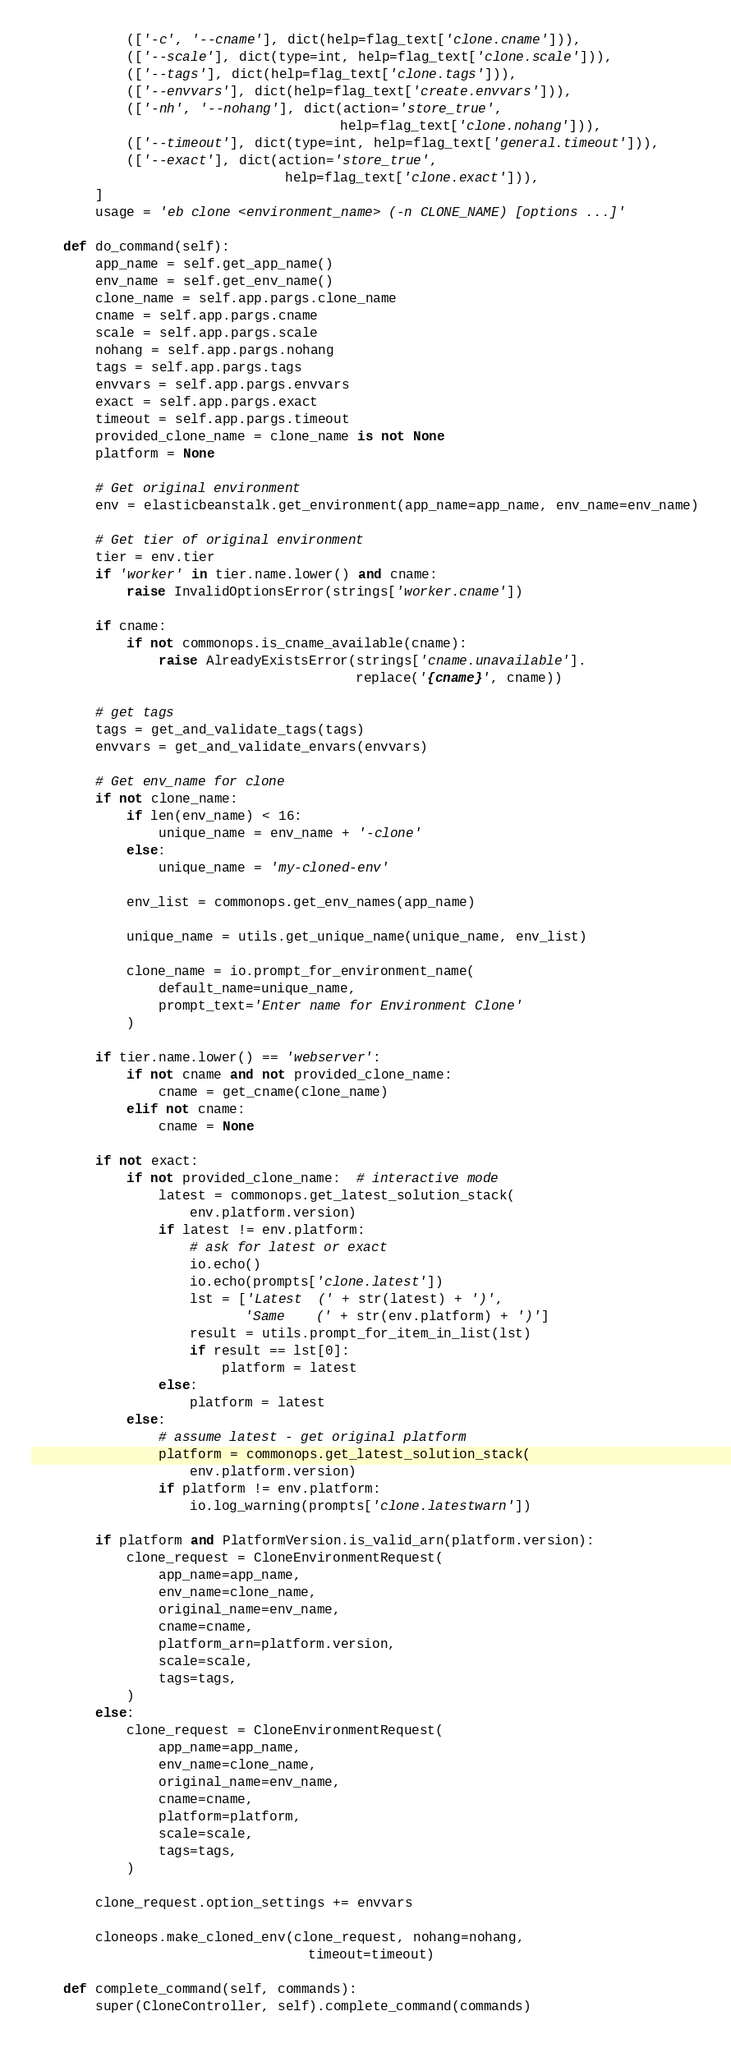<code> <loc_0><loc_0><loc_500><loc_500><_Python_>            (['-c', '--cname'], dict(help=flag_text['clone.cname'])),
            (['--scale'], dict(type=int, help=flag_text['clone.scale'])),
            (['--tags'], dict(help=flag_text['clone.tags'])),
            (['--envvars'], dict(help=flag_text['create.envvars'])),
            (['-nh', '--nohang'], dict(action='store_true',
                                       help=flag_text['clone.nohang'])),
            (['--timeout'], dict(type=int, help=flag_text['general.timeout'])),
            (['--exact'], dict(action='store_true',
                                help=flag_text['clone.exact'])),
        ]
        usage = 'eb clone <environment_name> (-n CLONE_NAME) [options ...]'

    def do_command(self):
        app_name = self.get_app_name()
        env_name = self.get_env_name()
        clone_name = self.app.pargs.clone_name
        cname = self.app.pargs.cname
        scale = self.app.pargs.scale
        nohang = self.app.pargs.nohang
        tags = self.app.pargs.tags
        envvars = self.app.pargs.envvars
        exact = self.app.pargs.exact
        timeout = self.app.pargs.timeout
        provided_clone_name = clone_name is not None
        platform = None

        # Get original environment
        env = elasticbeanstalk.get_environment(app_name=app_name, env_name=env_name)

        # Get tier of original environment
        tier = env.tier
        if 'worker' in tier.name.lower() and cname:
            raise InvalidOptionsError(strings['worker.cname'])

        if cname:
            if not commonops.is_cname_available(cname):
                raise AlreadyExistsError(strings['cname.unavailable'].
                                         replace('{cname}', cname))

        # get tags
        tags = get_and_validate_tags(tags)
        envvars = get_and_validate_envars(envvars)

        # Get env_name for clone
        if not clone_name:
            if len(env_name) < 16:
                unique_name = env_name + '-clone'
            else:
                unique_name = 'my-cloned-env'

            env_list = commonops.get_env_names(app_name)

            unique_name = utils.get_unique_name(unique_name, env_list)

            clone_name = io.prompt_for_environment_name(
                default_name=unique_name,
                prompt_text='Enter name for Environment Clone'
            )

        if tier.name.lower() == 'webserver':
            if not cname and not provided_clone_name:
                cname = get_cname(clone_name)
            elif not cname:
                cname = None

        if not exact:
            if not provided_clone_name:  # interactive mode
                latest = commonops.get_latest_solution_stack(
                    env.platform.version)
                if latest != env.platform:
                    # ask for latest or exact
                    io.echo()
                    io.echo(prompts['clone.latest'])
                    lst = ['Latest  (' + str(latest) + ')',
                           'Same    (' + str(env.platform) + ')']
                    result = utils.prompt_for_item_in_list(lst)
                    if result == lst[0]:
                        platform = latest
                else:
                    platform = latest
            else:
                # assume latest - get original platform
                platform = commonops.get_latest_solution_stack(
                    env.platform.version)
                if platform != env.platform:
                    io.log_warning(prompts['clone.latestwarn'])

        if platform and PlatformVersion.is_valid_arn(platform.version):
            clone_request = CloneEnvironmentRequest(
                app_name=app_name,
                env_name=clone_name,
                original_name=env_name,
                cname=cname,
                platform_arn=platform.version,
                scale=scale,
                tags=tags,
            )
        else:
            clone_request = CloneEnvironmentRequest(
                app_name=app_name,
                env_name=clone_name,
                original_name=env_name,
                cname=cname,
                platform=platform,
                scale=scale,
                tags=tags,
            )

        clone_request.option_settings += envvars

        cloneops.make_cloned_env(clone_request, nohang=nohang,
                                   timeout=timeout)

    def complete_command(self, commands):
        super(CloneController, self).complete_command(commands)</code> 